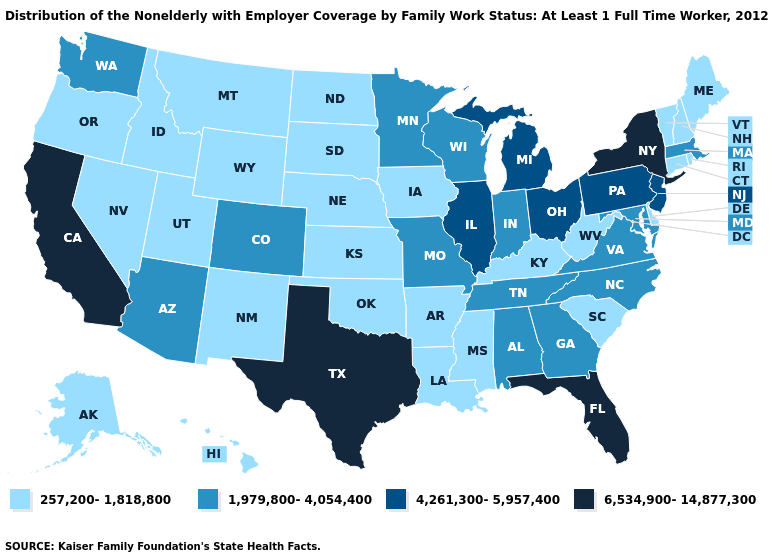What is the highest value in the MidWest ?
Write a very short answer. 4,261,300-5,957,400. How many symbols are there in the legend?
Concise answer only. 4. Which states have the highest value in the USA?
Short answer required. California, Florida, New York, Texas. Does Maine have the same value as Kentucky?
Be succinct. Yes. Does Iowa have the highest value in the MidWest?
Short answer required. No. Which states have the lowest value in the MidWest?
Be succinct. Iowa, Kansas, Nebraska, North Dakota, South Dakota. Among the states that border South Dakota , which have the highest value?
Concise answer only. Minnesota. Name the states that have a value in the range 257,200-1,818,800?
Write a very short answer. Alaska, Arkansas, Connecticut, Delaware, Hawaii, Idaho, Iowa, Kansas, Kentucky, Louisiana, Maine, Mississippi, Montana, Nebraska, Nevada, New Hampshire, New Mexico, North Dakota, Oklahoma, Oregon, Rhode Island, South Carolina, South Dakota, Utah, Vermont, West Virginia, Wyoming. How many symbols are there in the legend?
Short answer required. 4. Name the states that have a value in the range 257,200-1,818,800?
Concise answer only. Alaska, Arkansas, Connecticut, Delaware, Hawaii, Idaho, Iowa, Kansas, Kentucky, Louisiana, Maine, Mississippi, Montana, Nebraska, Nevada, New Hampshire, New Mexico, North Dakota, Oklahoma, Oregon, Rhode Island, South Carolina, South Dakota, Utah, Vermont, West Virginia, Wyoming. Does Nevada have a lower value than Oregon?
Short answer required. No. What is the value of Oregon?
Keep it brief. 257,200-1,818,800. Name the states that have a value in the range 1,979,800-4,054,400?
Concise answer only. Alabama, Arizona, Colorado, Georgia, Indiana, Maryland, Massachusetts, Minnesota, Missouri, North Carolina, Tennessee, Virginia, Washington, Wisconsin. Does Kentucky have a lower value than Maryland?
Short answer required. Yes. What is the lowest value in the Northeast?
Answer briefly. 257,200-1,818,800. 